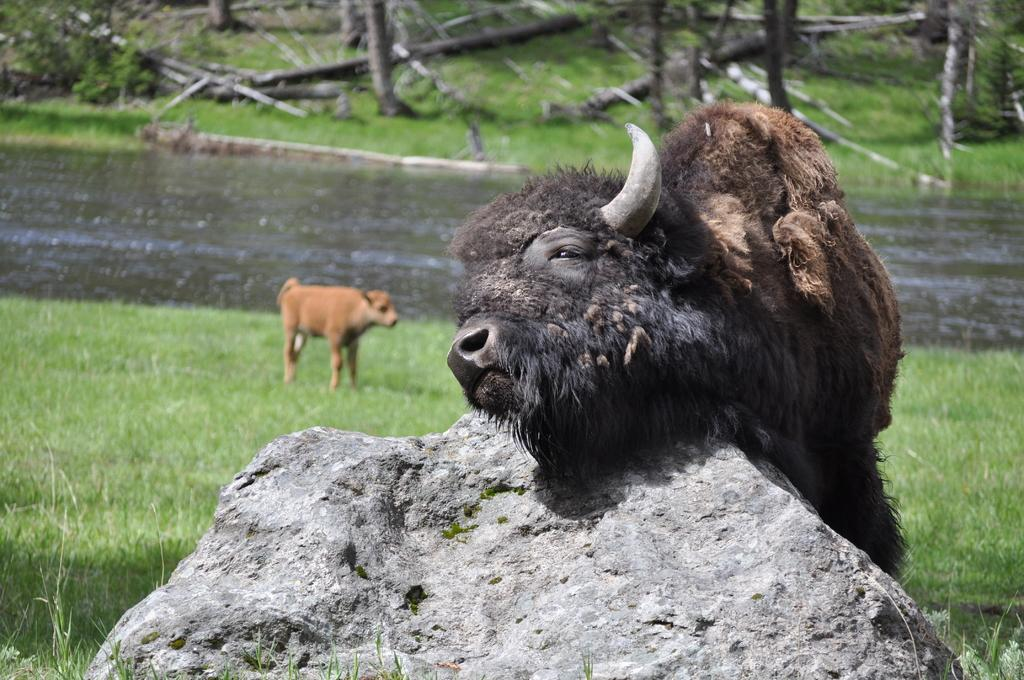What is located in the center of the image? There are animals in the center of the image. What is present at the bottom of the image? There is a rock and grass at the bottom of the image. What can be seen in the background of the image? There is water and trees visible in the background of the image. How many pancakes are floating on the water in the background of the image? There are no pancakes visible in the image; it features animals, a rock, grass, water, and trees in the background. What type of boats can be seen navigating the water in the background of the image? There are no boats present in the image; it features animals, a rock, grass, water, and trees in the background. 